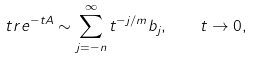<formula> <loc_0><loc_0><loc_500><loc_500>\ t r e ^ { - t A } \sim \sum _ { j = - n } ^ { \infty } t ^ { - j / m } b _ { j } , \quad t \to 0 ,</formula> 